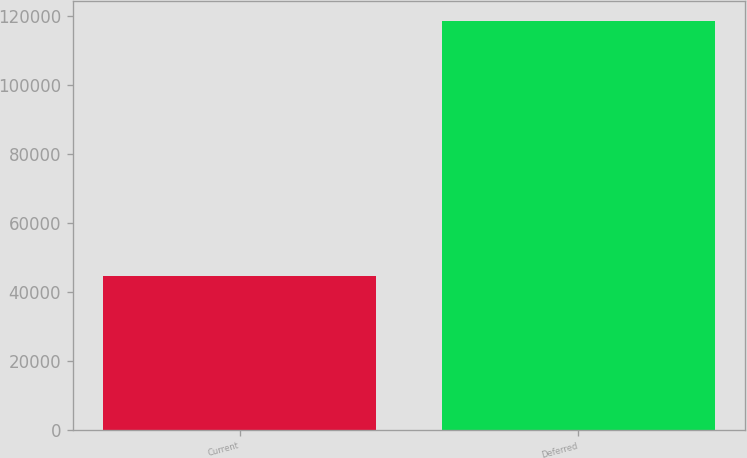<chart> <loc_0><loc_0><loc_500><loc_500><bar_chart><fcel>Current<fcel>Deferred<nl><fcel>44579<fcel>118351<nl></chart> 